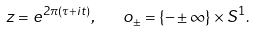<formula> <loc_0><loc_0><loc_500><loc_500>z = e ^ { 2 \pi \left ( \tau + i t \right ) } , \text { \ \ } o _ { \pm } = \left \{ - \pm \infty \right \} \times S ^ { 1 } .</formula> 